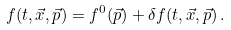Convert formula to latex. <formula><loc_0><loc_0><loc_500><loc_500>f ( t , \vec { x } , \vec { p } ) = f ^ { 0 } ( \vec { p } ) + \delta f ( t , \vec { x } , \vec { p } ) \, .</formula> 